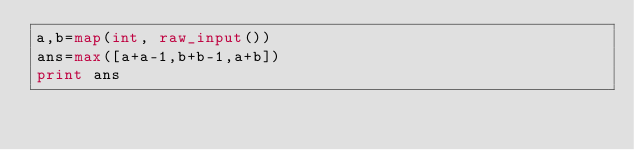<code> <loc_0><loc_0><loc_500><loc_500><_Python_>a,b=map(int, raw_input())
ans=max([a+a-1,b+b-1,a+b])
print ans

</code> 